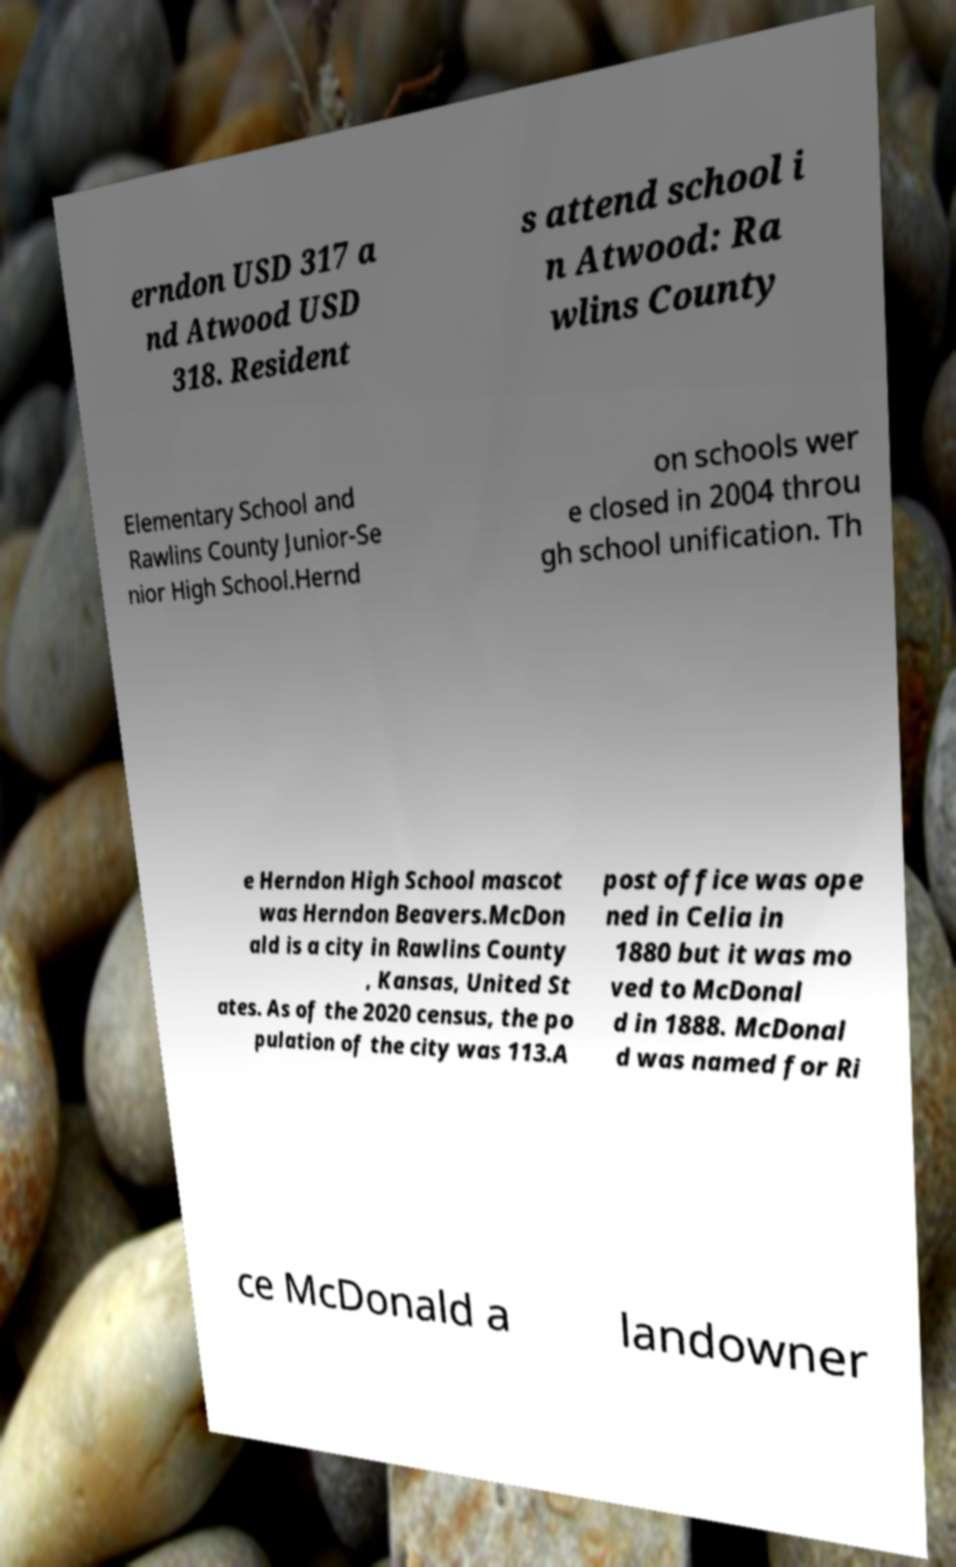Can you accurately transcribe the text from the provided image for me? erndon USD 317 a nd Atwood USD 318. Resident s attend school i n Atwood: Ra wlins County Elementary School and Rawlins County Junior-Se nior High School.Hernd on schools wer e closed in 2004 throu gh school unification. Th e Herndon High School mascot was Herndon Beavers.McDon ald is a city in Rawlins County , Kansas, United St ates. As of the 2020 census, the po pulation of the city was 113.A post office was ope ned in Celia in 1880 but it was mo ved to McDonal d in 1888. McDonal d was named for Ri ce McDonald a landowner 